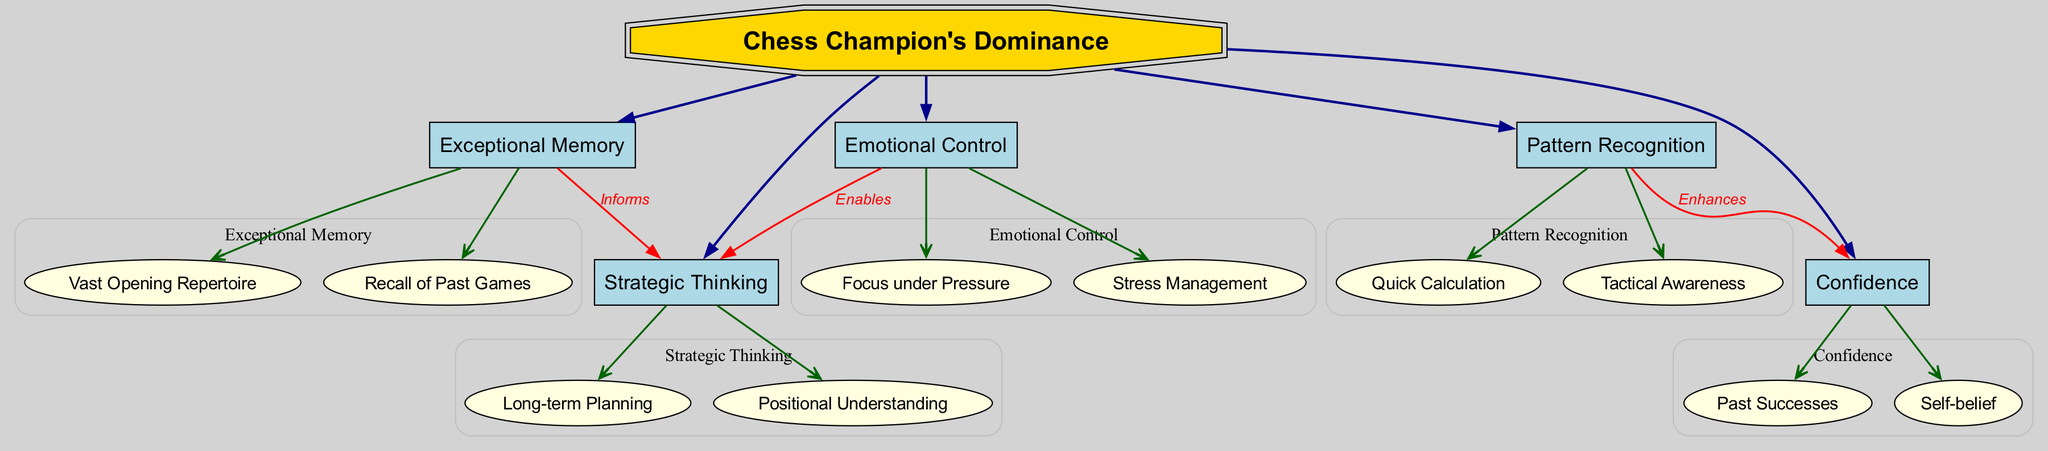What is the central concept of the diagram? The central concept is explicitly labeled at the top of the diagram, depicted in a double octagon shape. It is stated as "Chess Champion's Dominance."
Answer: Chess Champion's Dominance How many main factors contribute to the chess champion's dominance? The diagram lists five main factors as rectangles connected to the central concept. These factors are "Exceptional Memory," "Strategic Thinking," "Emotional Control," "Pattern Recognition," and "Confidence."
Answer: 5 Which subfactor is associated with Emotional Control? In the diagram, Emotional Control has two subfactors: "Stress Management" and "Focus under Pressure." Both are represented in an ellipse shape connected to Emotional Control.
Answer: Stress Management What connection enhances confidence? The diagram shows an arrow labeled "Enhances" leading from "Pattern Recognition" to "Confidence," indicating that pattern recognition plays a role in enhancing confidence.
Answer: Pattern Recognition Which two main factors inform strategic thinking? Referring to the connections in the diagram, "Exceptional Memory" directly connects to "Strategic Thinking" with an "Informs" label, meaning it provides knowledge that contributes to strategic thinking. Additionally, "Emotional Control" is also indicated to enable strategic thinking.
Answer: Exceptional Memory, Emotional Control What is the color of the main factors in the diagram? The main factors are represented in a distinct style, specifically colored in light blue, which is consistently used throughout the diagram for these nodes.
Answer: Light blue How does emotional control enable strategic thinking? The diagram provides a direct connection labeled "Enables" from "Emotional Control" to "Strategic Thinking." This indicates that emotional control is a facilitating factor for effective strategic thinking, allowing for clearer, more rational thought processes despite pressure.
Answer: Enables What relationship does stress management have with emotional control? Stress Management is a subfactor directly connected to Emotional Control, indicating that it is part of the broader concept of emotional control that contributes to a player's mental stability.
Answer: Part of Emotional Control 